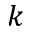<formula> <loc_0><loc_0><loc_500><loc_500>k</formula> 